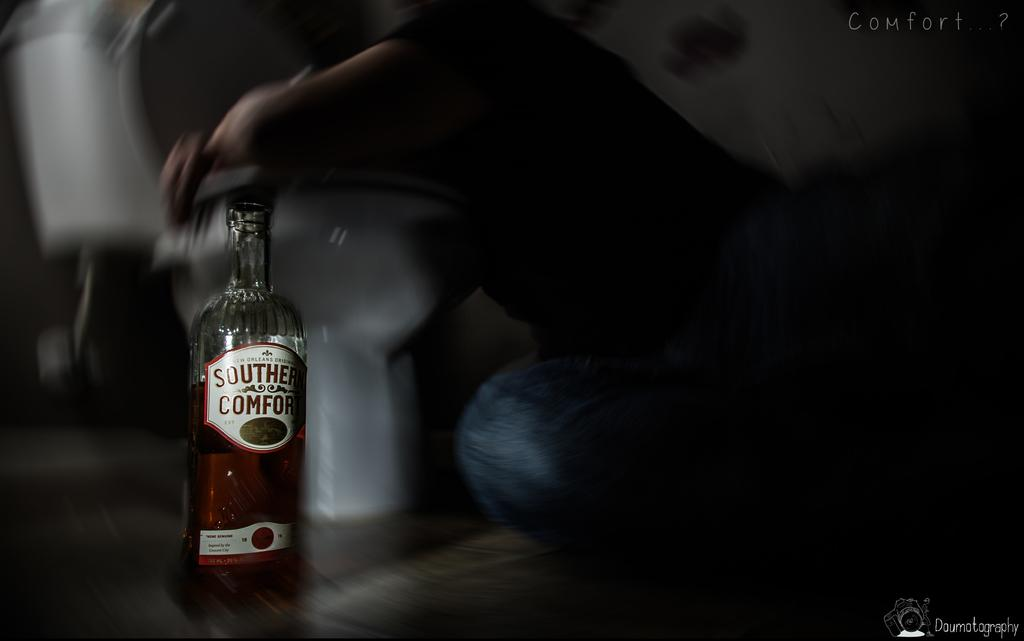What object can be seen in the image? There is a bottle in the image. What type of shade is covering the bottle in the image? There is no shade covering the bottle in the image; it is not mentioned in the provided facts. 